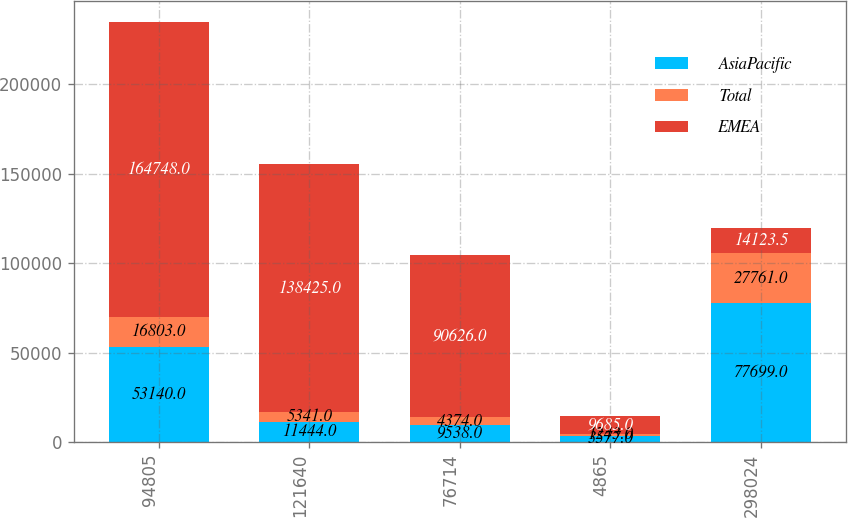<chart> <loc_0><loc_0><loc_500><loc_500><stacked_bar_chart><ecel><fcel>94805<fcel>121640<fcel>76714<fcel>4865<fcel>298024<nl><fcel>AsiaPacific<fcel>53140<fcel>11444<fcel>9538<fcel>3577<fcel>77699<nl><fcel>Total<fcel>16803<fcel>5341<fcel>4374<fcel>1243<fcel>27761<nl><fcel>EMEA<fcel>164748<fcel>138425<fcel>90626<fcel>9685<fcel>14123.5<nl></chart> 